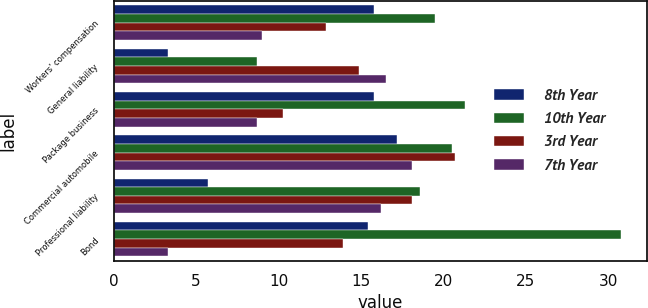Convert chart to OTSL. <chart><loc_0><loc_0><loc_500><loc_500><stacked_bar_chart><ecel><fcel>Workers' compensation<fcel>General liability<fcel>Package business<fcel>Commercial automobile<fcel>Professional liability<fcel>Bond<nl><fcel>8th Year<fcel>15.8<fcel>3.3<fcel>15.8<fcel>17.2<fcel>5.7<fcel>15.4<nl><fcel>10th Year<fcel>19.5<fcel>8.7<fcel>21.3<fcel>20.5<fcel>18.6<fcel>30.8<nl><fcel>3rd Year<fcel>12.9<fcel>14.9<fcel>10.3<fcel>20.7<fcel>18.1<fcel>13.9<nl><fcel>7th Year<fcel>9<fcel>16.5<fcel>8.7<fcel>18.1<fcel>16.2<fcel>3.3<nl></chart> 